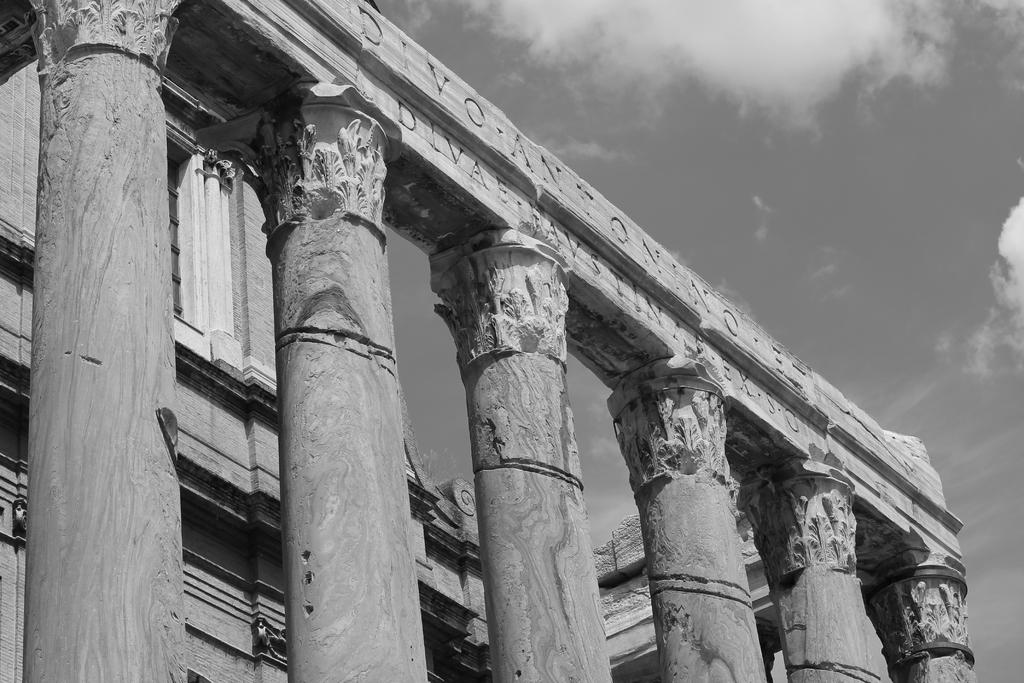What type of structure is present in the image? There is a building in the image. What architectural feature can be seen at the front of the building? The building has pillars in the front. What is written or displayed on the beam at the top of the building? There is text on a beam at the top of the building. What can be seen in the sky at the top of the image? Clouds are visible in the sky at the top of the image. How many roses are placed on the chairs in the image? There are no roses or chairs present in the image. 